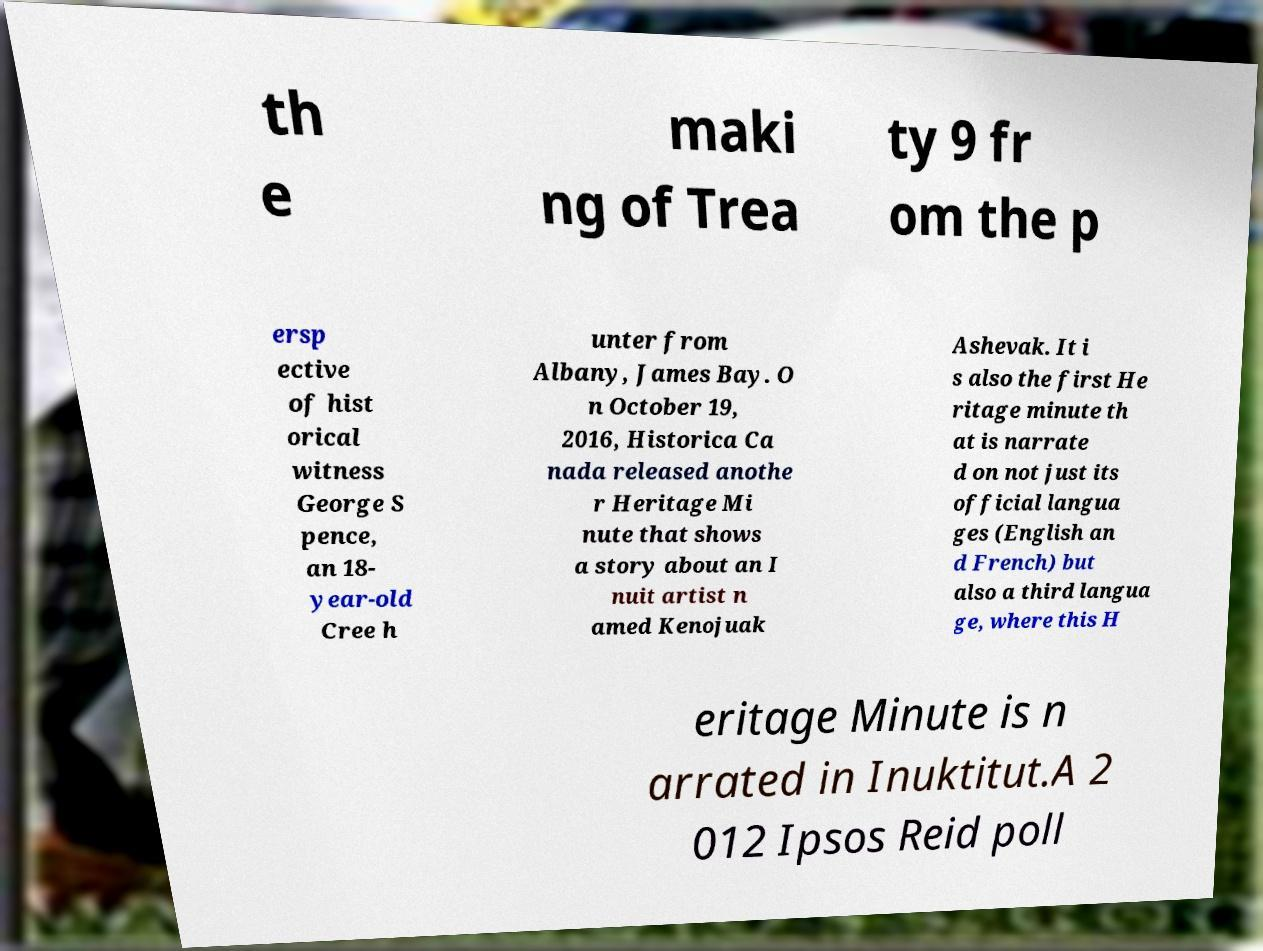Please identify and transcribe the text found in this image. th e maki ng of Trea ty 9 fr om the p ersp ective of hist orical witness George S pence, an 18- year-old Cree h unter from Albany, James Bay. O n October 19, 2016, Historica Ca nada released anothe r Heritage Mi nute that shows a story about an I nuit artist n amed Kenojuak Ashevak. It i s also the first He ritage minute th at is narrate d on not just its official langua ges (English an d French) but also a third langua ge, where this H eritage Minute is n arrated in Inuktitut.A 2 012 Ipsos Reid poll 